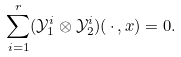Convert formula to latex. <formula><loc_0><loc_0><loc_500><loc_500>\sum _ { i = 1 } ^ { r } ( \mathcal { Y } _ { 1 } ^ { i } \otimes \mathcal { Y } _ { 2 } ^ { i } ) ( \, \cdot \, , x ) = 0 .</formula> 